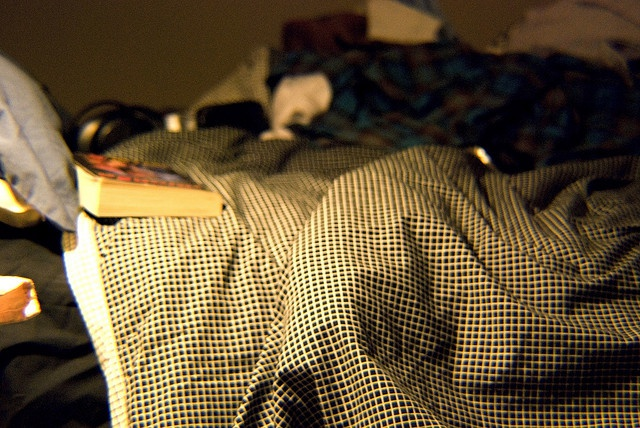Describe the objects in this image and their specific colors. I can see bed in black, olive, maroon, and khaki tones and book in black, gold, brown, orange, and khaki tones in this image. 